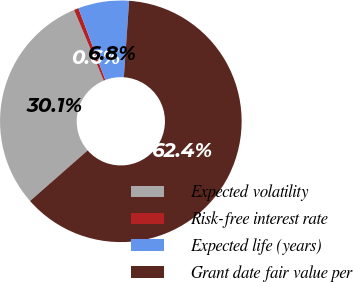Convert chart to OTSL. <chart><loc_0><loc_0><loc_500><loc_500><pie_chart><fcel>Expected volatility<fcel>Risk-free interest rate<fcel>Expected life (years)<fcel>Grant date fair value per<nl><fcel>30.14%<fcel>0.62%<fcel>6.8%<fcel>62.44%<nl></chart> 